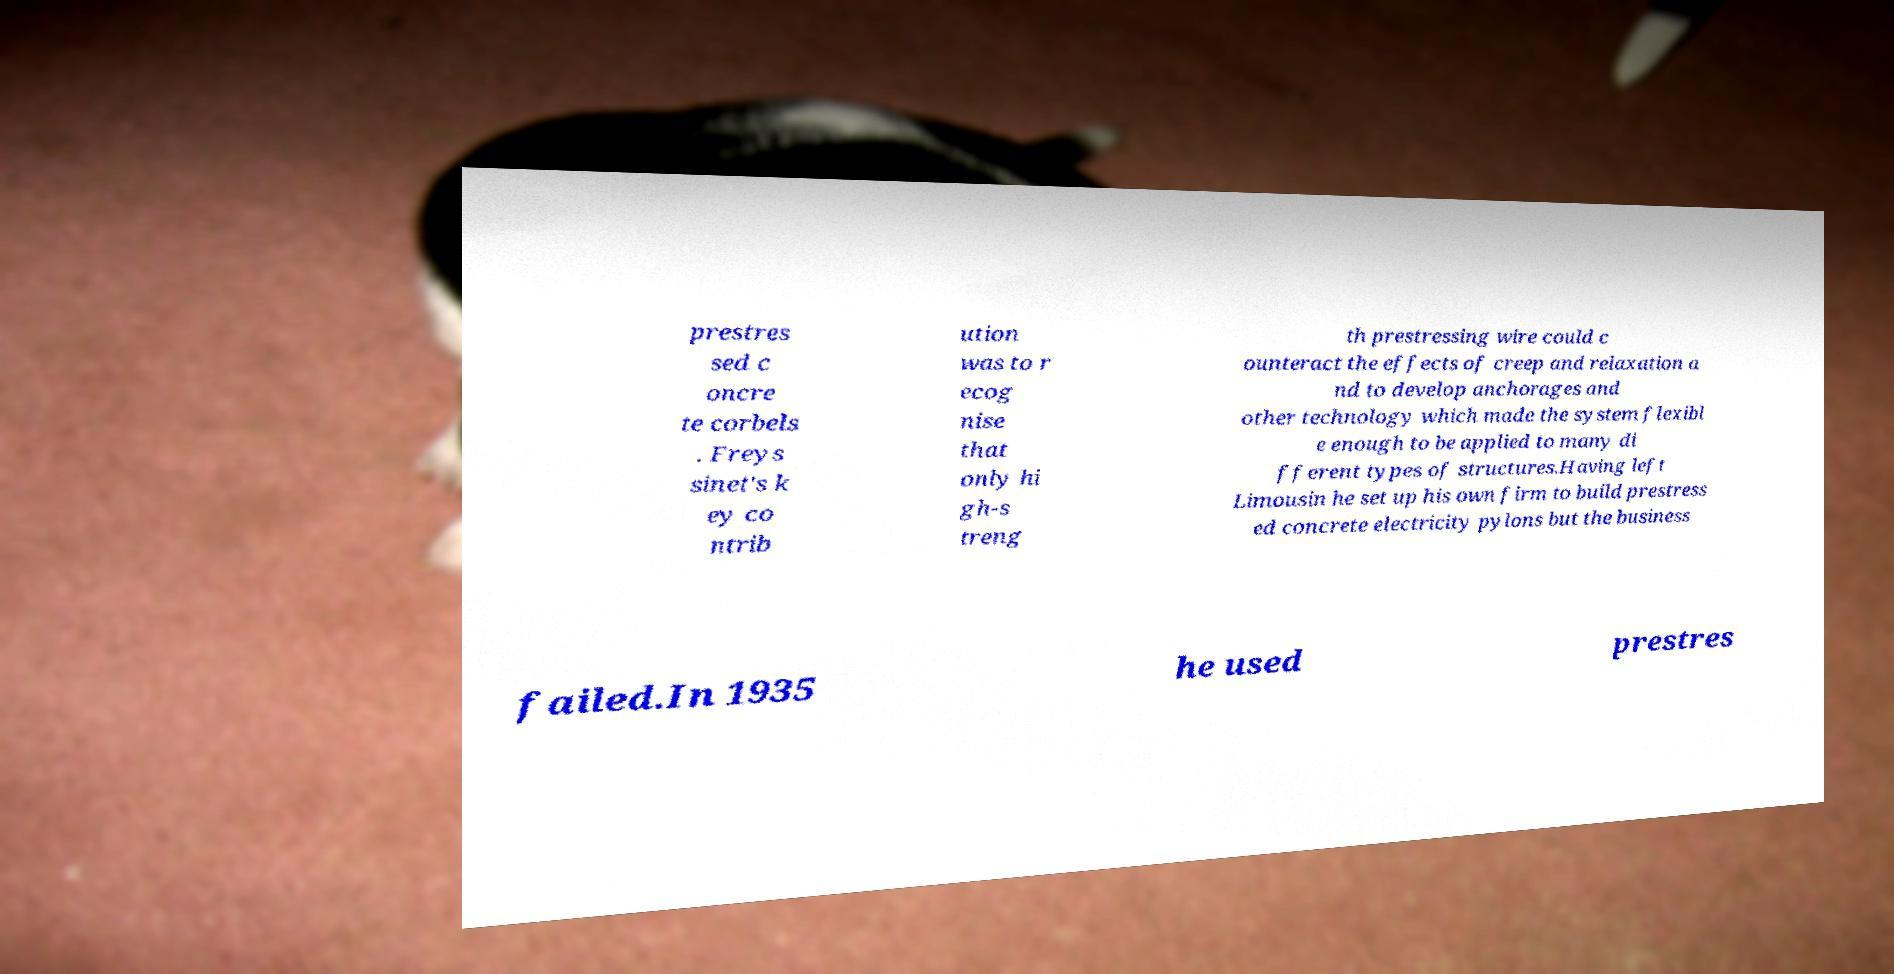Please read and relay the text visible in this image. What does it say? prestres sed c oncre te corbels . Freys sinet's k ey co ntrib ution was to r ecog nise that only hi gh-s treng th prestressing wire could c ounteract the effects of creep and relaxation a nd to develop anchorages and other technology which made the system flexibl e enough to be applied to many di fferent types of structures.Having left Limousin he set up his own firm to build prestress ed concrete electricity pylons but the business failed.In 1935 he used prestres 